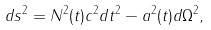<formula> <loc_0><loc_0><loc_500><loc_500>d s ^ { 2 } = N ^ { 2 } ( t ) c ^ { 2 } d t ^ { 2 } - a ^ { 2 } ( t ) d \Omega ^ { 2 } ,</formula> 